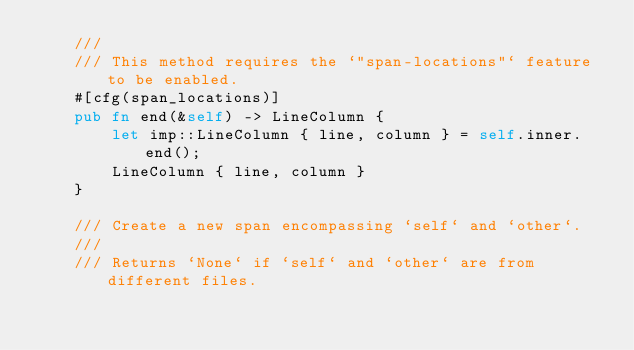<code> <loc_0><loc_0><loc_500><loc_500><_Rust_>    ///
    /// This method requires the `"span-locations"` feature to be enabled.
    #[cfg(span_locations)]
    pub fn end(&self) -> LineColumn {
        let imp::LineColumn { line, column } = self.inner.end();
        LineColumn { line, column }
    }

    /// Create a new span encompassing `self` and `other`.
    ///
    /// Returns `None` if `self` and `other` are from different files.</code> 